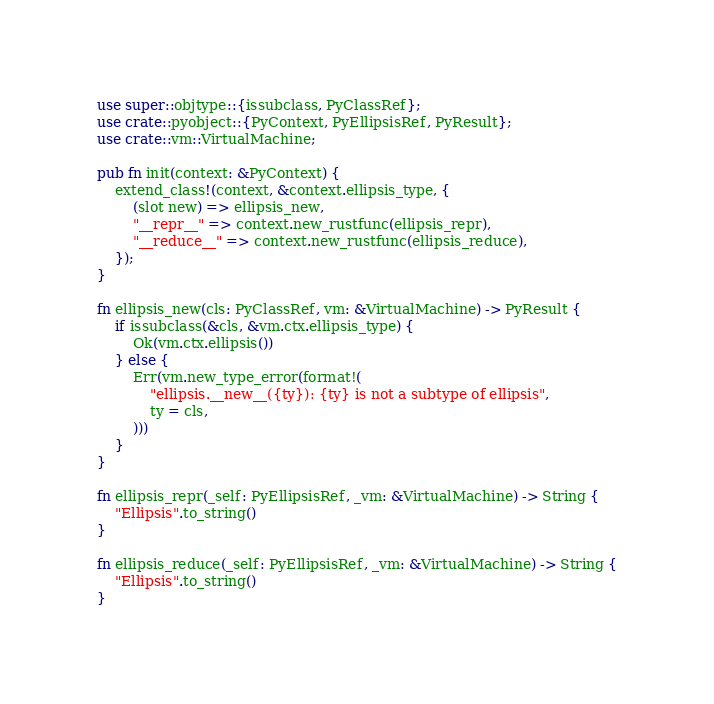Convert code to text. <code><loc_0><loc_0><loc_500><loc_500><_Rust_>use super::objtype::{issubclass, PyClassRef};
use crate::pyobject::{PyContext, PyEllipsisRef, PyResult};
use crate::vm::VirtualMachine;

pub fn init(context: &PyContext) {
    extend_class!(context, &context.ellipsis_type, {
        (slot new) => ellipsis_new,
        "__repr__" => context.new_rustfunc(ellipsis_repr),
        "__reduce__" => context.new_rustfunc(ellipsis_reduce),
    });
}

fn ellipsis_new(cls: PyClassRef, vm: &VirtualMachine) -> PyResult {
    if issubclass(&cls, &vm.ctx.ellipsis_type) {
        Ok(vm.ctx.ellipsis())
    } else {
        Err(vm.new_type_error(format!(
            "ellipsis.__new__({ty}): {ty} is not a subtype of ellipsis",
            ty = cls,
        )))
    }
}

fn ellipsis_repr(_self: PyEllipsisRef, _vm: &VirtualMachine) -> String {
    "Ellipsis".to_string()
}

fn ellipsis_reduce(_self: PyEllipsisRef, _vm: &VirtualMachine) -> String {
    "Ellipsis".to_string()
}
</code> 